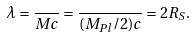<formula> <loc_0><loc_0><loc_500><loc_500>\lambda = \frac { } { M c } = \frac { } { ( M _ { P l } / 2 ) c } = 2 R _ { S } .</formula> 